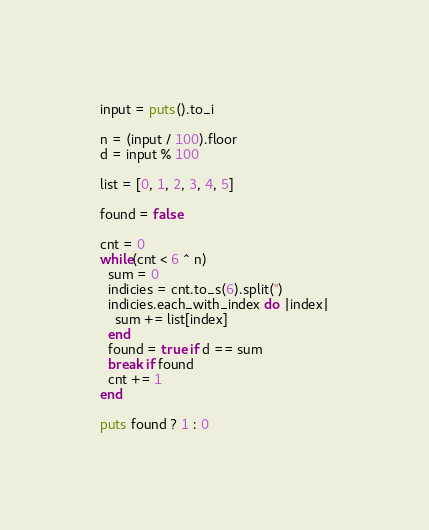<code> <loc_0><loc_0><loc_500><loc_500><_Ruby_>input = puts().to_i

n = (input / 100).floor
d = input % 100

list = [0, 1, 2, 3, 4, 5]

found = false

cnt = 0
while(cnt < 6 ^ n)
  sum = 0
  indicies = cnt.to_s(6).split('')
  indicies.each_with_index do |index|
    sum += list[index]
  end
  found = true if d == sum
  break if found
  cnt += 1
end

puts found ? 1 : 0</code> 